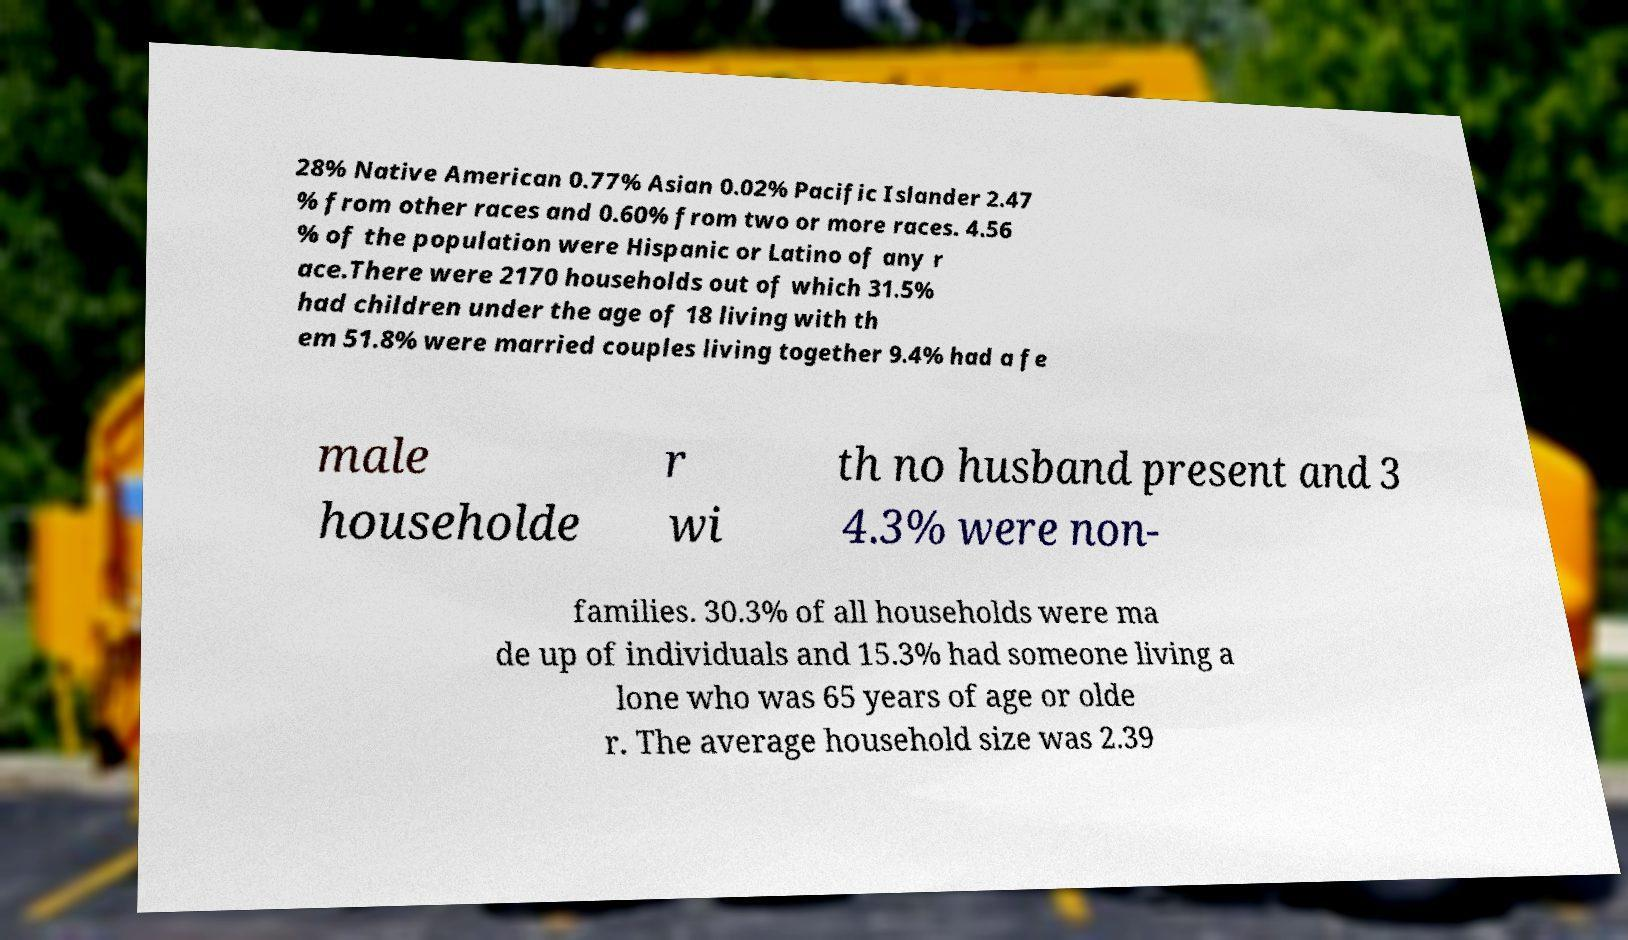Please identify and transcribe the text found in this image. 28% Native American 0.77% Asian 0.02% Pacific Islander 2.47 % from other races and 0.60% from two or more races. 4.56 % of the population were Hispanic or Latino of any r ace.There were 2170 households out of which 31.5% had children under the age of 18 living with th em 51.8% were married couples living together 9.4% had a fe male householde r wi th no husband present and 3 4.3% were non- families. 30.3% of all households were ma de up of individuals and 15.3% had someone living a lone who was 65 years of age or olde r. The average household size was 2.39 